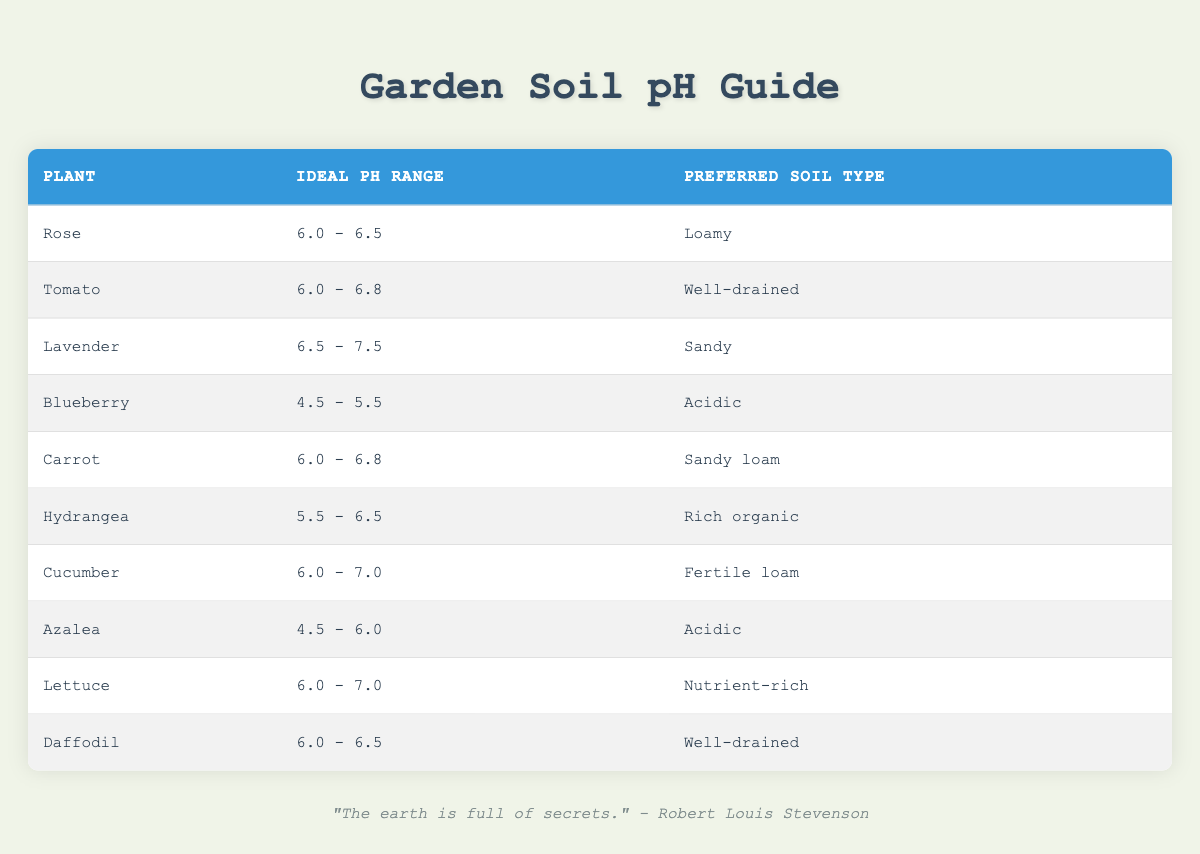What is the ideal pH range for Blueberry? According to the table, the ideal pH range for Blueberry is listed directly in the second column under the Blueberry row, which states "4.5 - 5.5".
Answer: 4.5 - 5.5 Which plant prefers sandy soil? By looking at the preferred soil types in the third column, both Lavender and Carrot are listed as preferring Sandy soil, which is further corroborated by their respective rows.
Answer: Lavender and Carrot Is the ideal pH range for Azalea higher than that for Rose? To answer this, we compare the pH ranges of both plants. Azalea's pH range is "4.5 - 6.0" while Rose's range is "6.0 - 6.5". Since 4.5 - 6.0 is lower than 6.0 - 6.5, Azalea's ideal pH range is not higher than that of Rose.
Answer: No What is the average ideal pH range for plants that prefer well-drained soil? The plants preferring well-drained soil in the table are Tomato and Daffodil. Their pH ranges are 6.0 - 6.8 and 6.0 - 6.5, respectively. To find the average, we calculate the midpoint of their ranges: Tomato (6.4) and Daffodil (6.25). The average of 6.4 and 6.25 is (6.4 + 6.25) / 2 = 6.325, thus the average ideal pH range is 6.325.
Answer: 6.325 Do both Lettuce and Cucumber have the same ideal pH range? The table shows Lettuce has an ideal pH range of "6.0 - 7.0" while Cucumber also has a pH range of "6.0 - 7.0". Since both are identical, we can say they have the same ideal pH range.
Answer: Yes Which plant has the broadest ideal pH range? To determine this, we compare the ranges provided for each plant. Examing the ranges, Lavender’s ideal pH range of "6.5 - 7.5" spans a full 1.0 units. However, Blueberry has "4.5 - 5.5" which also spans 1.0 units, while others span less. After comparing all, Lavender has the broadest range.
Answer: Lavender What type of soil do Carrots prefer? By directly looking at the preferred soil type of Carrot in the third column, it is seen that Carrots prefer "Sandy loam".
Answer: Sandy loam 